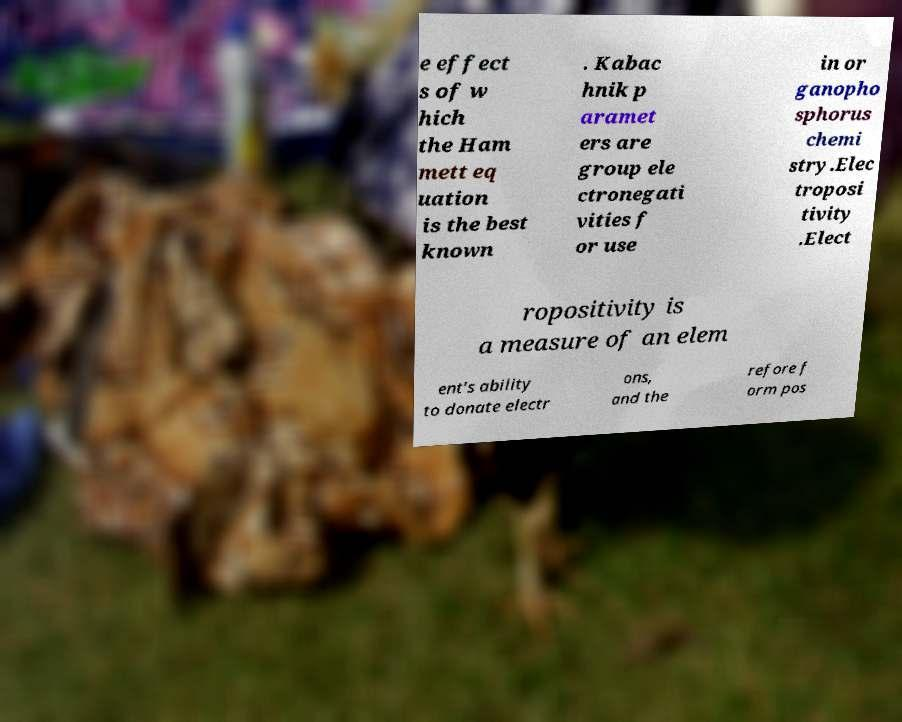Please identify and transcribe the text found in this image. e effect s of w hich the Ham mett eq uation is the best known . Kabac hnik p aramet ers are group ele ctronegati vities f or use in or ganopho sphorus chemi stry.Elec troposi tivity .Elect ropositivity is a measure of an elem ent's ability to donate electr ons, and the refore f orm pos 